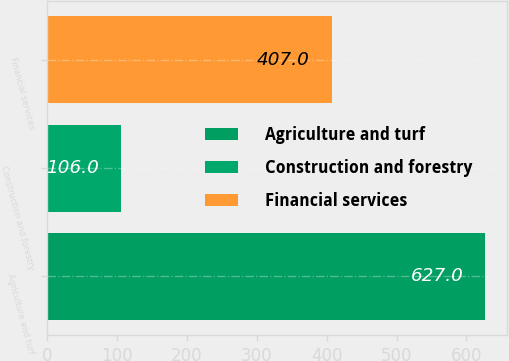Convert chart to OTSL. <chart><loc_0><loc_0><loc_500><loc_500><bar_chart><fcel>Agriculture and turf<fcel>Construction and forestry<fcel>Financial services<nl><fcel>627<fcel>106<fcel>407<nl></chart> 